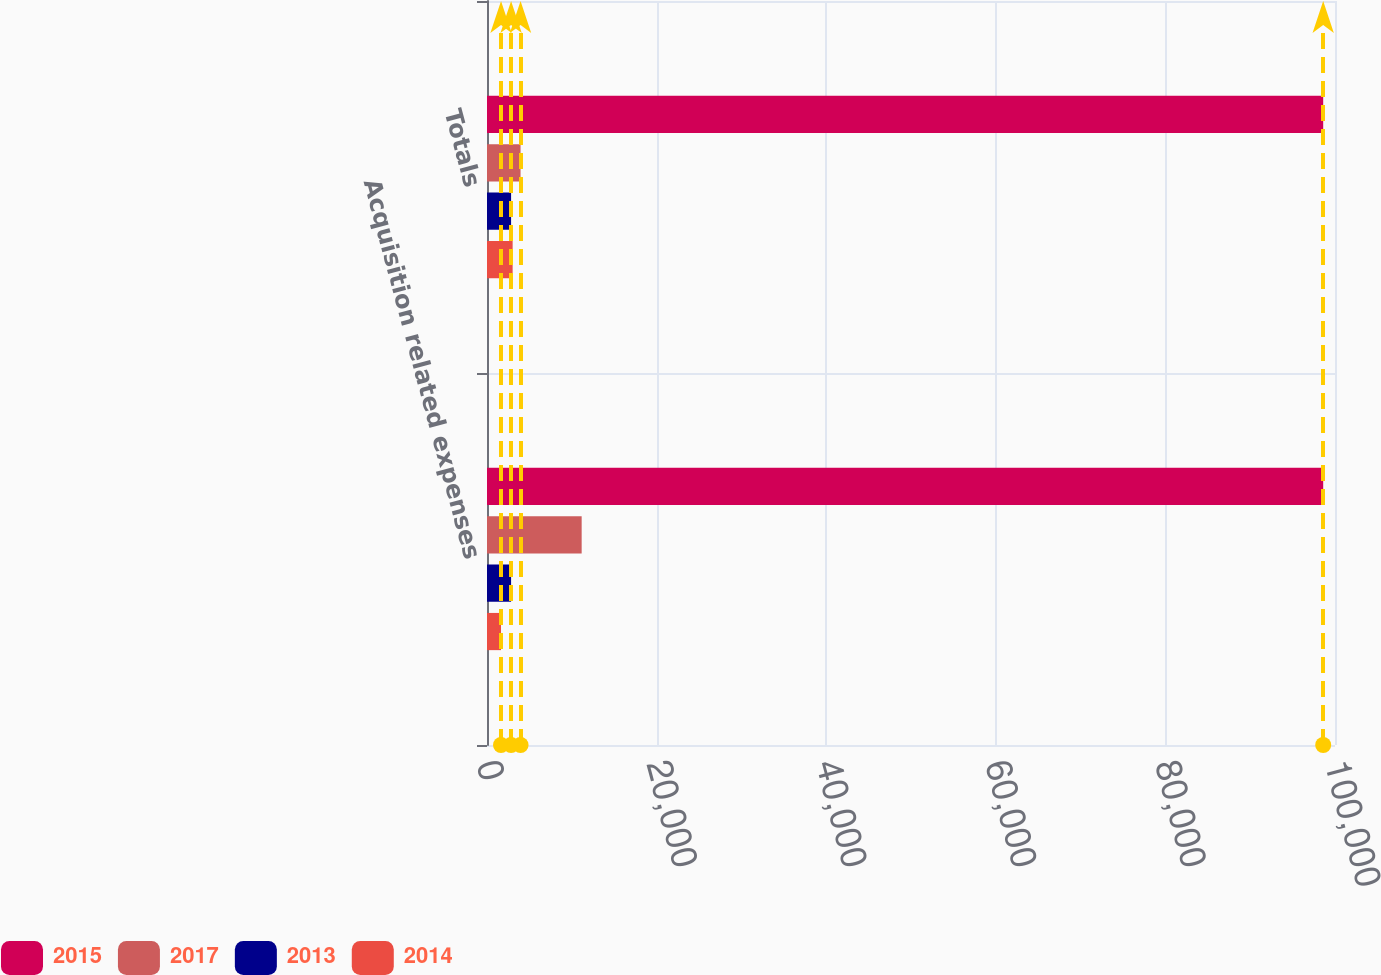<chart> <loc_0><loc_0><loc_500><loc_500><stacked_bar_chart><ecel><fcel>Acquisition related expenses<fcel>Totals<nl><fcel>2015<fcel>98608<fcel>98608<nl><fcel>2017<fcel>11163<fcel>3957<nl><fcel>2013<fcel>2840<fcel>2840<nl><fcel>2014<fcel>1654<fcel>3024<nl></chart> 